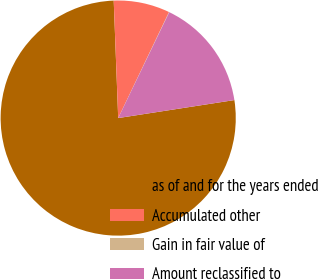Convert chart. <chart><loc_0><loc_0><loc_500><loc_500><pie_chart><fcel>as of and for the years ended<fcel>Accumulated other<fcel>Gain in fair value of<fcel>Amount reclassified to<nl><fcel>76.84%<fcel>7.72%<fcel>0.04%<fcel>15.4%<nl></chart> 